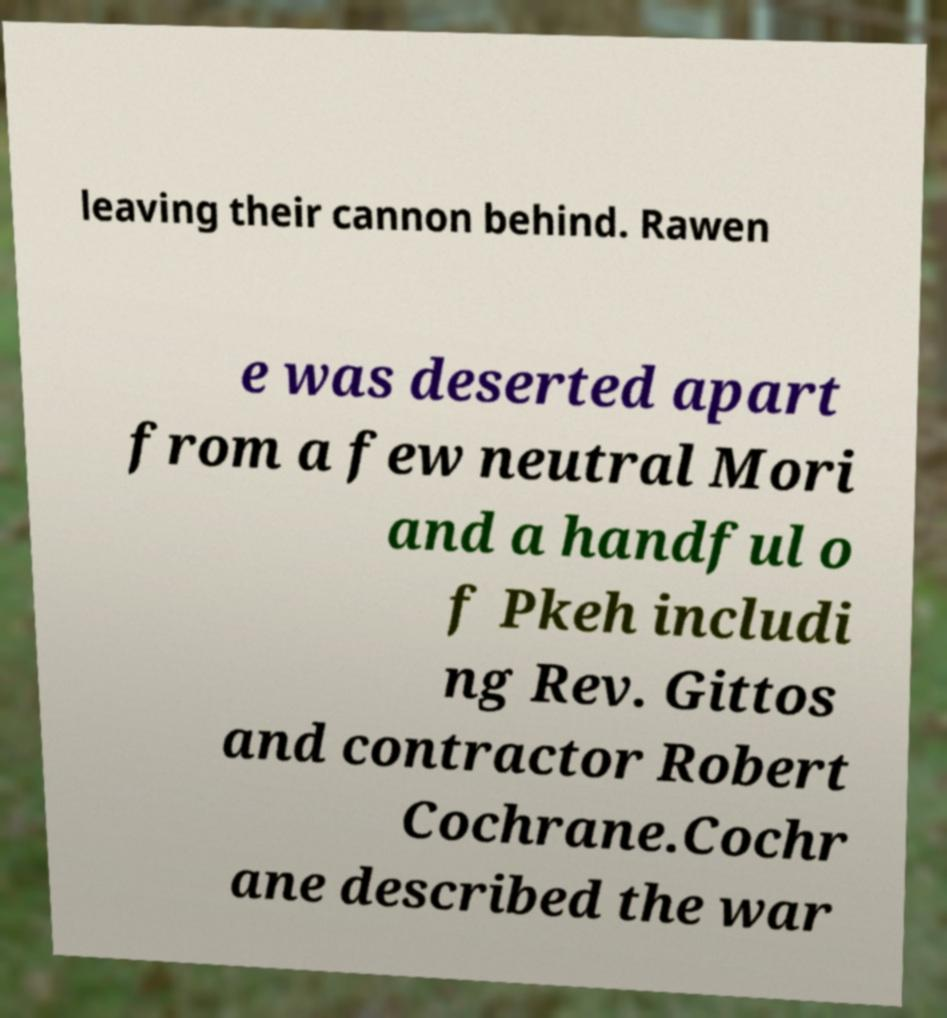There's text embedded in this image that I need extracted. Can you transcribe it verbatim? leaving their cannon behind. Rawen e was deserted apart from a few neutral Mori and a handful o f Pkeh includi ng Rev. Gittos and contractor Robert Cochrane.Cochr ane described the war 